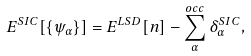Convert formula to latex. <formula><loc_0><loc_0><loc_500><loc_500>E ^ { S I C } [ \{ \psi _ { \alpha } \} ] = E ^ { L S D } [ n ] - \sum _ { \alpha } ^ { o c c } \delta _ { \alpha } ^ { S I C } ,</formula> 